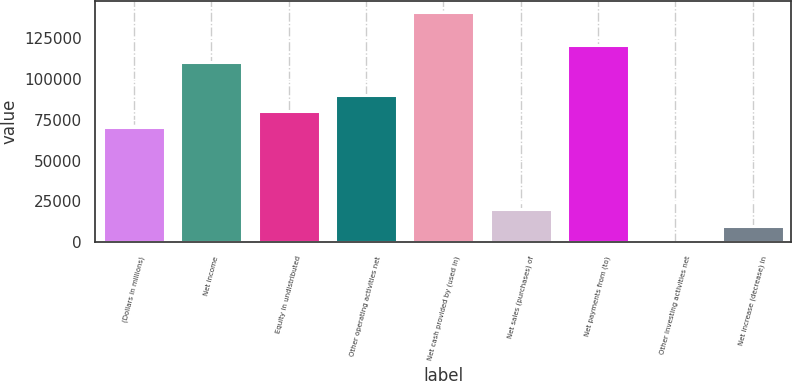<chart> <loc_0><loc_0><loc_500><loc_500><bar_chart><fcel>(Dollars in millions)<fcel>Net income<fcel>Equity in undistributed<fcel>Other operating activities net<fcel>Net cash provided by (used in)<fcel>Net sales (purchases) of<fcel>Net payments from (to)<fcel>Other investing activities net<fcel>Net increase (decrease) in<nl><fcel>70218.5<fcel>110332<fcel>80247<fcel>90275.5<fcel>140418<fcel>20076<fcel>120361<fcel>19<fcel>10047.5<nl></chart> 